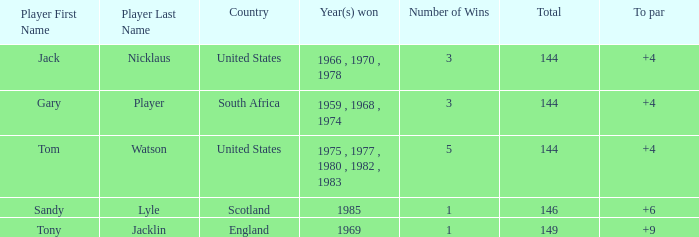What was Tom Watson's lowest To par when the total was larger than 144? None. 